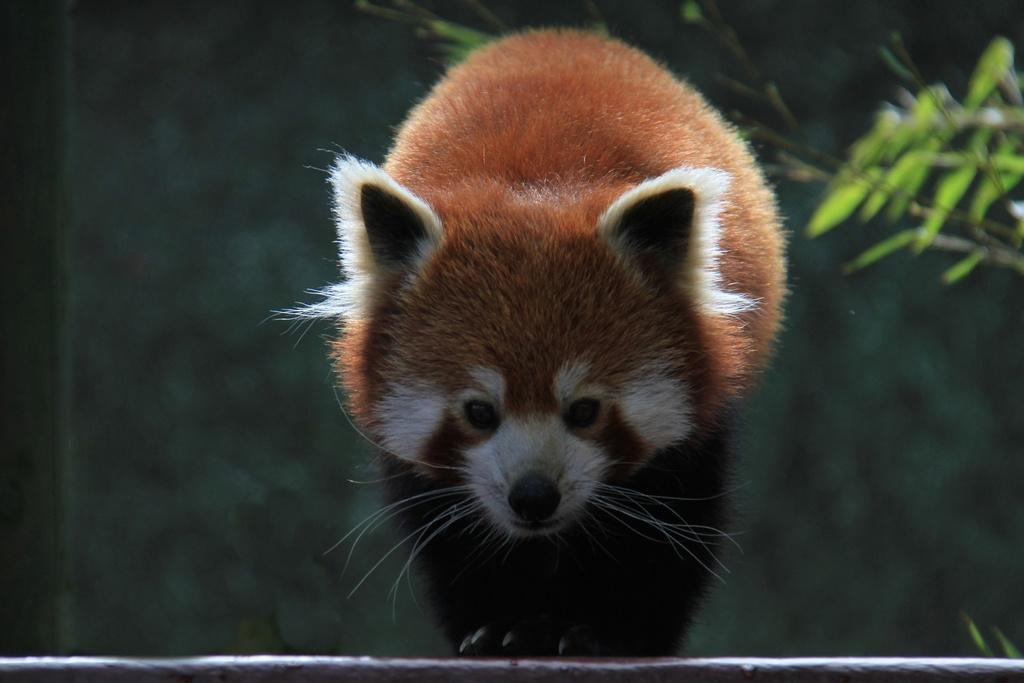What animal is depicted in the image? There is a picture of a red panda in the image. Where is the red panda located in the image? The red panda is in the middle of the image. What other elements can be seen in the image besides the red panda? There are leaves of a plant life or a natural setting. Is there a table in the image where the red panda is playing chess? No, there is no table or chess game present in the image. The image only shows a picture of a red panda and leaves of a plant. 